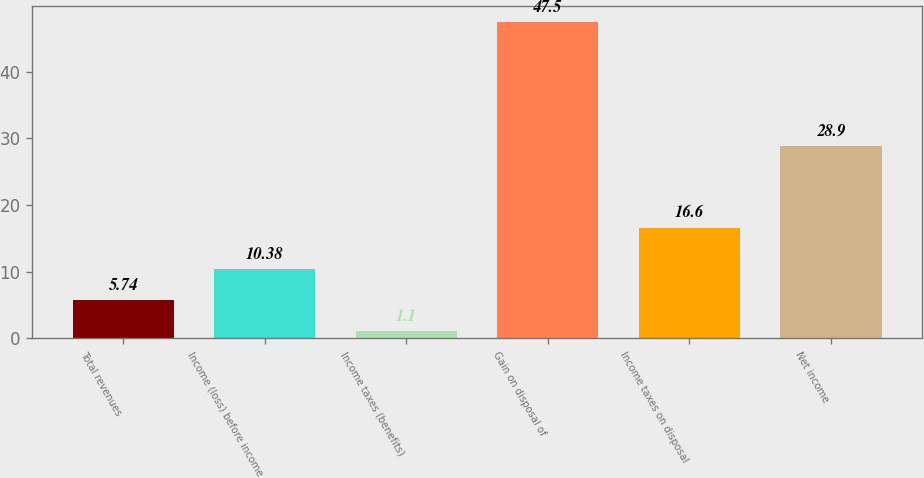Convert chart to OTSL. <chart><loc_0><loc_0><loc_500><loc_500><bar_chart><fcel>Total revenues<fcel>Income (loss) before income<fcel>Income taxes (benefits)<fcel>Gain on disposal of<fcel>Income taxes on disposal<fcel>Net income<nl><fcel>5.74<fcel>10.38<fcel>1.1<fcel>47.5<fcel>16.6<fcel>28.9<nl></chart> 